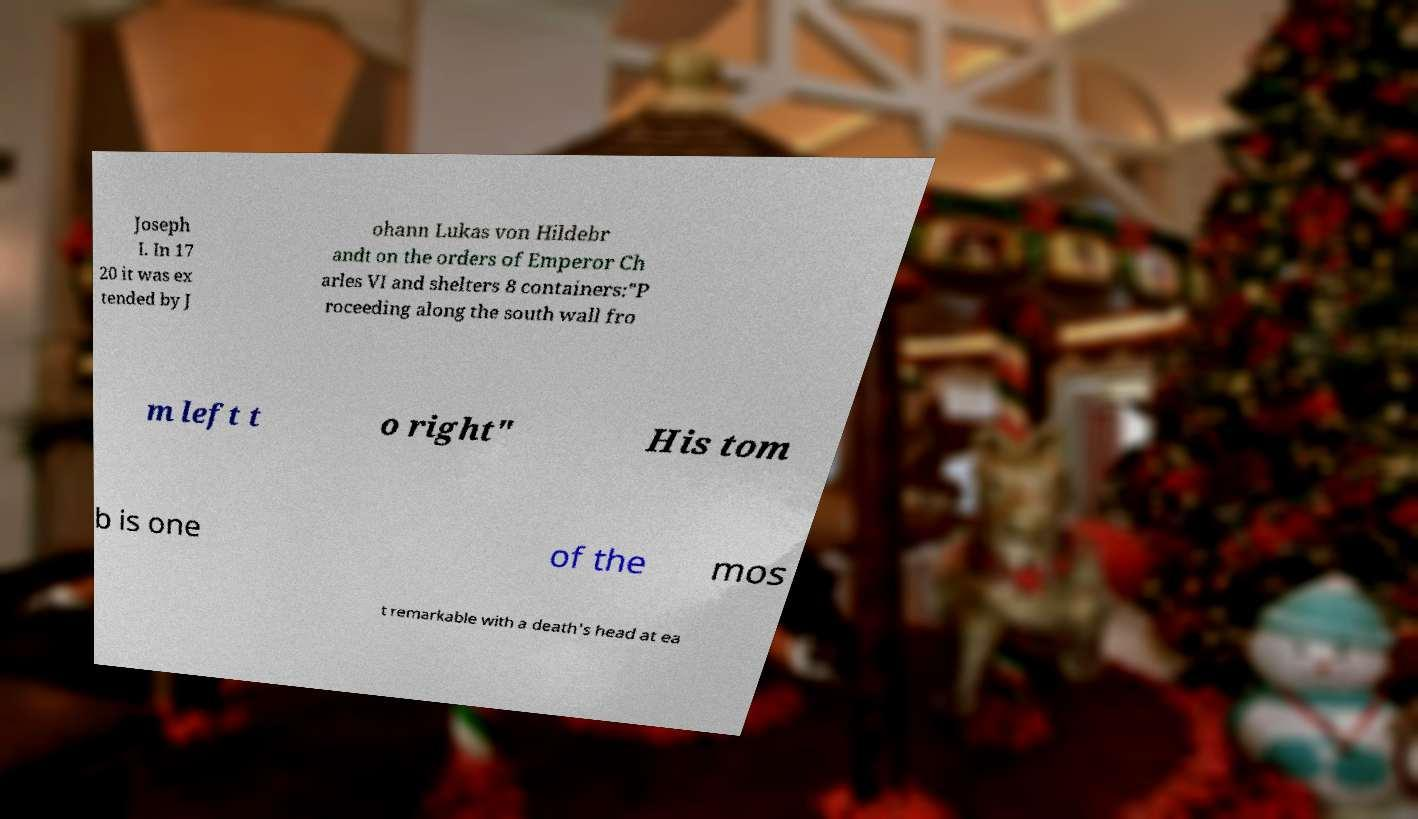Please read and relay the text visible in this image. What does it say? Joseph I. In 17 20 it was ex tended by J ohann Lukas von Hildebr andt on the orders of Emperor Ch arles VI and shelters 8 containers:"P roceeding along the south wall fro m left t o right" His tom b is one of the mos t remarkable with a death's head at ea 